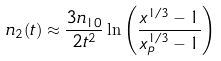Convert formula to latex. <formula><loc_0><loc_0><loc_500><loc_500>n _ { 2 } ( t ) \approx \frac { 3 n _ { 1 0 } } { 2 t ^ { 2 } } \ln \left ( \frac { x ^ { 1 / 3 } - 1 } { x _ { p } ^ { 1 / 3 } - 1 } \right )</formula> 